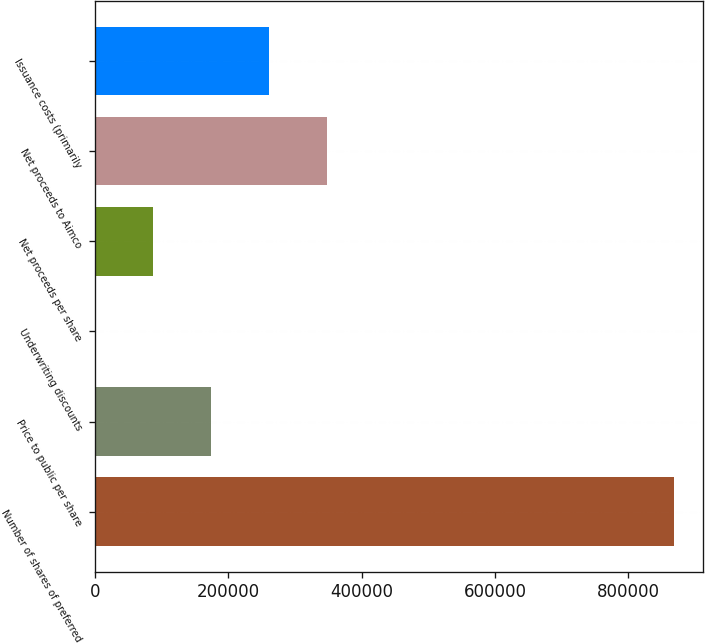Convert chart. <chart><loc_0><loc_0><loc_500><loc_500><bar_chart><fcel>Number of shares of preferred<fcel>Price to public per share<fcel>Underwriting discounts<fcel>Net proceeds per share<fcel>Net proceeds to Aimco<fcel>Issuance costs (primarily<nl><fcel>869153<fcel>173832<fcel>1.25<fcel>86916.4<fcel>347662<fcel>260747<nl></chart> 